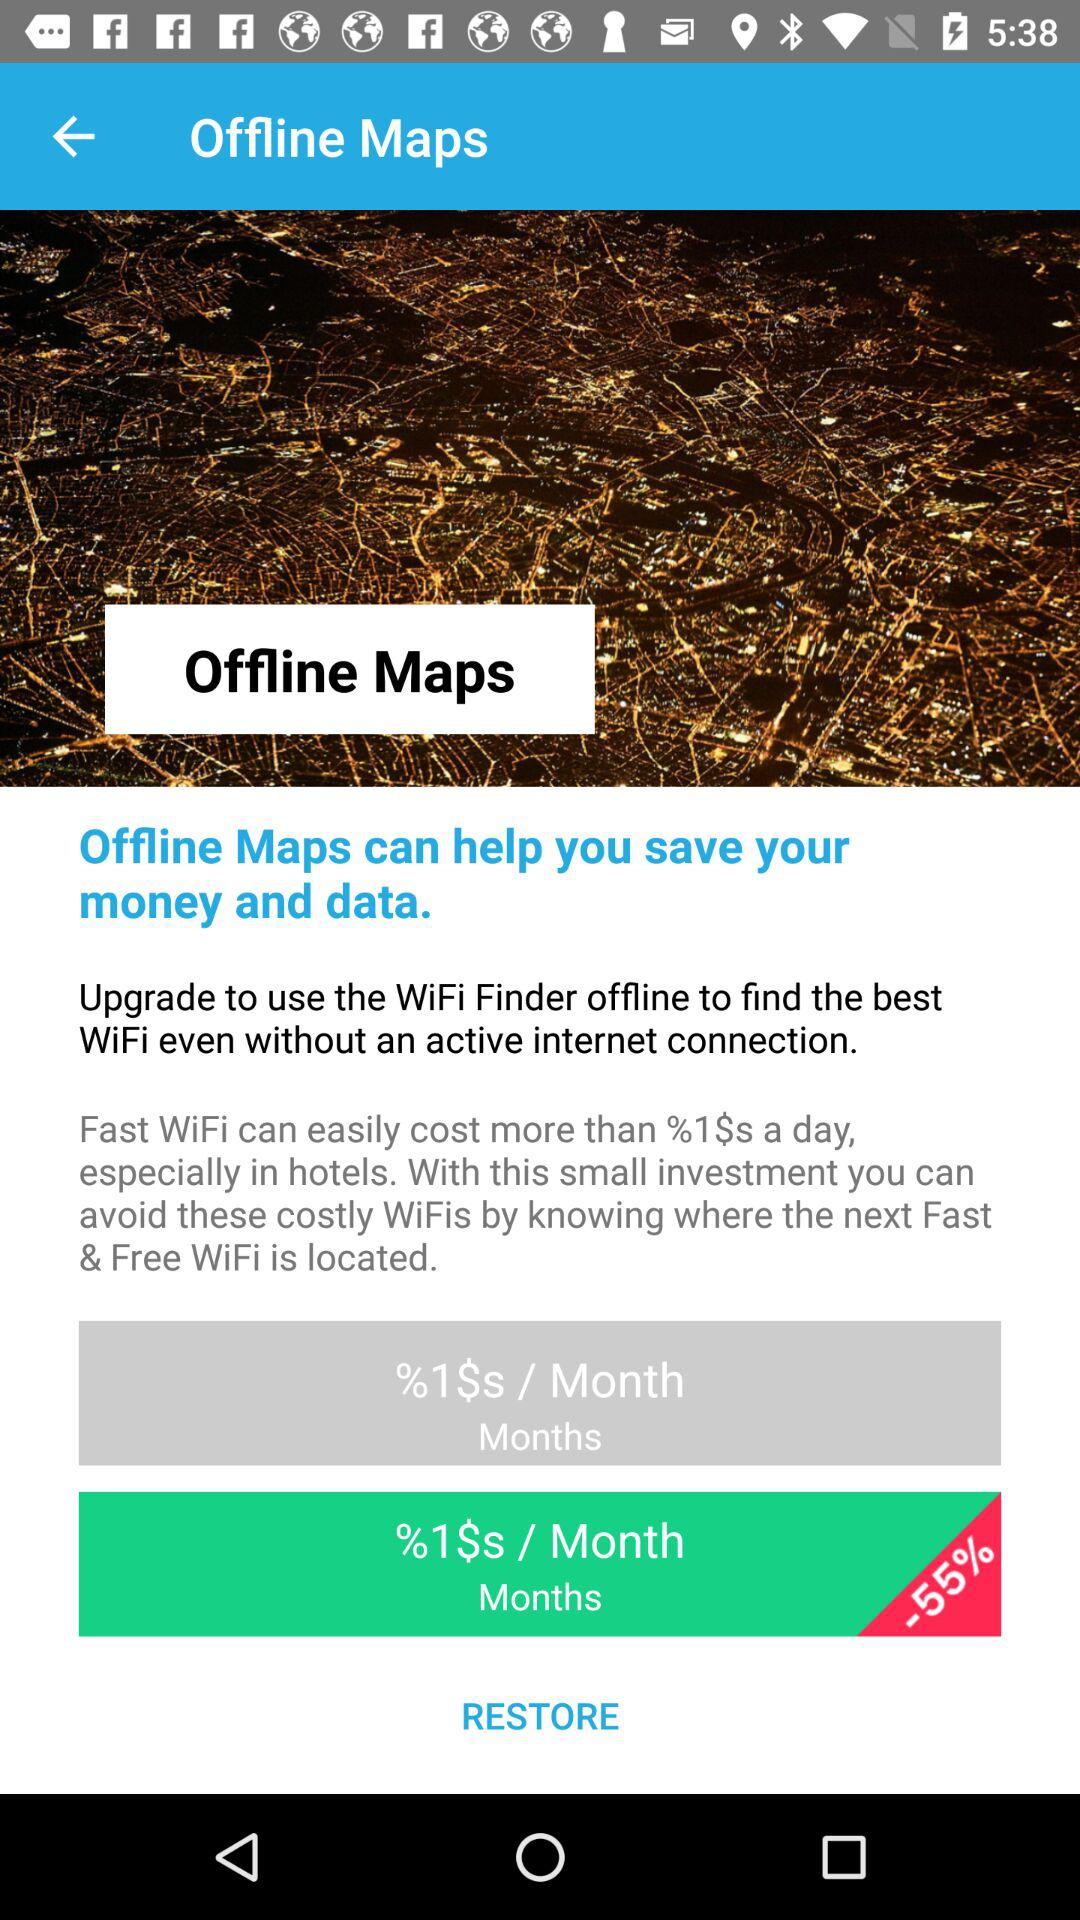What is the given percentage discount? The given percentage discount is 55. 